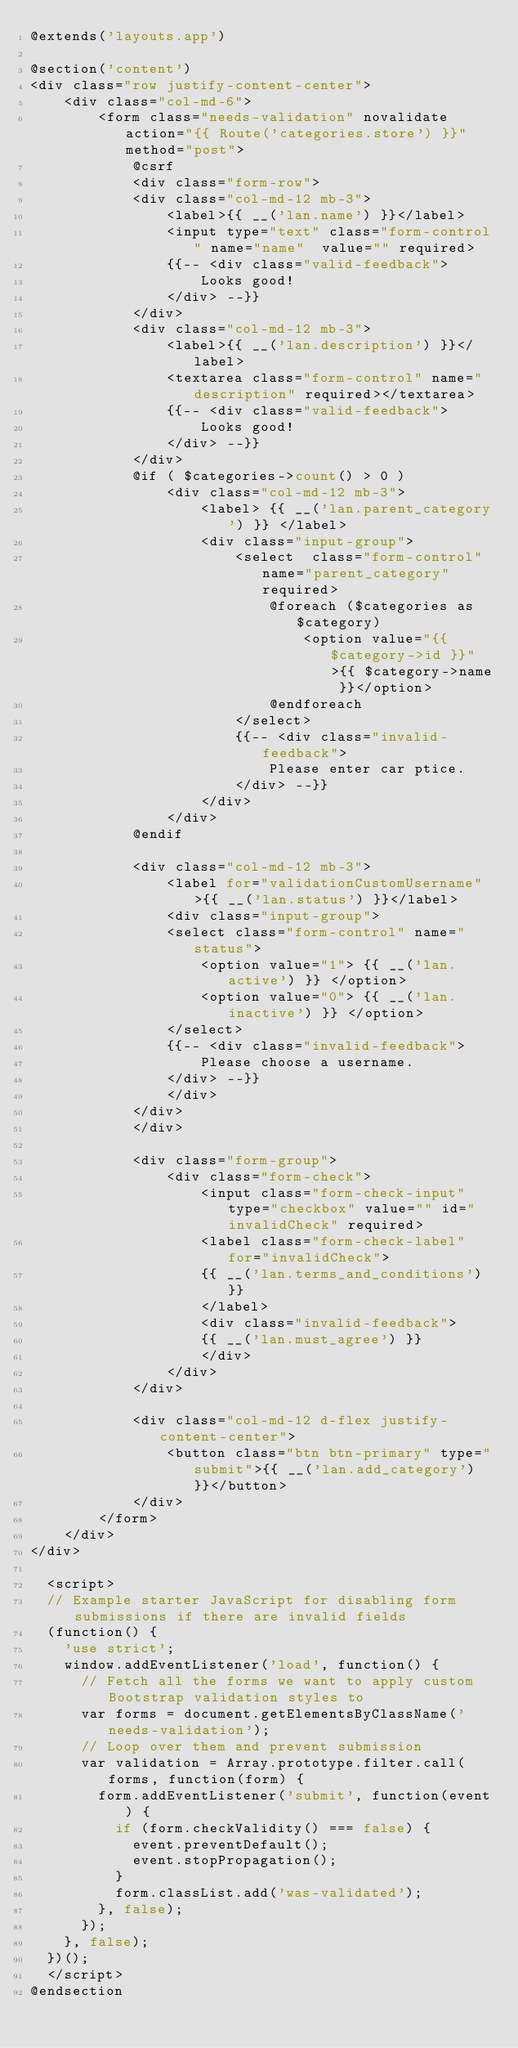Convert code to text. <code><loc_0><loc_0><loc_500><loc_500><_PHP_>@extends('layouts.app')

@section('content')
<div class="row justify-content-center">
    <div class="col-md-6">
        <form class="needs-validation" novalidate action="{{ Route('categories.store') }}" method="post">
            @csrf
            <div class="form-row">
            <div class="col-md-12 mb-3">
                <label>{{ __('lan.name') }}</label>
                <input type="text" class="form-control" name="name"  value="" required>
                {{-- <div class="valid-feedback">
                    Looks good!
                </div> --}}
            </div>
            <div class="col-md-12 mb-3">
                <label>{{ __('lan.description') }}</label>
                <textarea class="form-control" name="description" required></textarea>
                {{-- <div class="valid-feedback">
                    Looks good!
                </div> --}}
            </div>
            @if ( $categories->count() > 0 )
                <div class="col-md-12 mb-3">
                    <label> {{ __('lan.parent_category') }} </label>
                    <div class="input-group">
                        <select  class="form-control" name="parent_category" required>
                            @foreach ($categories as $category)
                                <option value="{{ $category->id }}">{{ $category->name }}</option>
                            @endforeach
                        </select>
                        {{-- <div class="invalid-feedback">
                            Please enter car ptice.
                        </div> --}}
                    </div>
                </div>
            @endif

            <div class="col-md-12 mb-3">
                <label for="validationCustomUsername">{{ __('lan.status') }}</label>
                <div class="input-group">
                <select class="form-control" name="status">
                    <option value="1"> {{ __('lan.active') }} </option>
                    <option value="0"> {{ __('lan.inactive') }} </option>
                </select>
                {{-- <div class="invalid-feedback">
                    Please choose a username.
                </div> --}}
                </div>
            </div>
            </div>

            <div class="form-group">
                <div class="form-check">
                    <input class="form-check-input" type="checkbox" value="" id="invalidCheck" required>
                    <label class="form-check-label" for="invalidCheck">
                    {{ __('lan.terms_and_conditions') }}
                    </label>
                    <div class="invalid-feedback">
                    {{ __('lan.must_agree') }}
                    </div>
                </div>
            </div>

            <div class="col-md-12 d-flex justify-content-center">
                <button class="btn btn-primary" type="submit">{{ __('lan.add_category') }}</button>
            </div>
        </form>
    </div>
</div>

  <script>
  // Example starter JavaScript for disabling form submissions if there are invalid fields
  (function() {
    'use strict';
    window.addEventListener('load', function() {
      // Fetch all the forms we want to apply custom Bootstrap validation styles to
      var forms = document.getElementsByClassName('needs-validation');
      // Loop over them and prevent submission
      var validation = Array.prototype.filter.call(forms, function(form) {
        form.addEventListener('submit', function(event) {
          if (form.checkValidity() === false) {
            event.preventDefault();
            event.stopPropagation();
          }
          form.classList.add('was-validated');
        }, false);
      });
    }, false);
  })();
  </script>
@endsection
</code> 